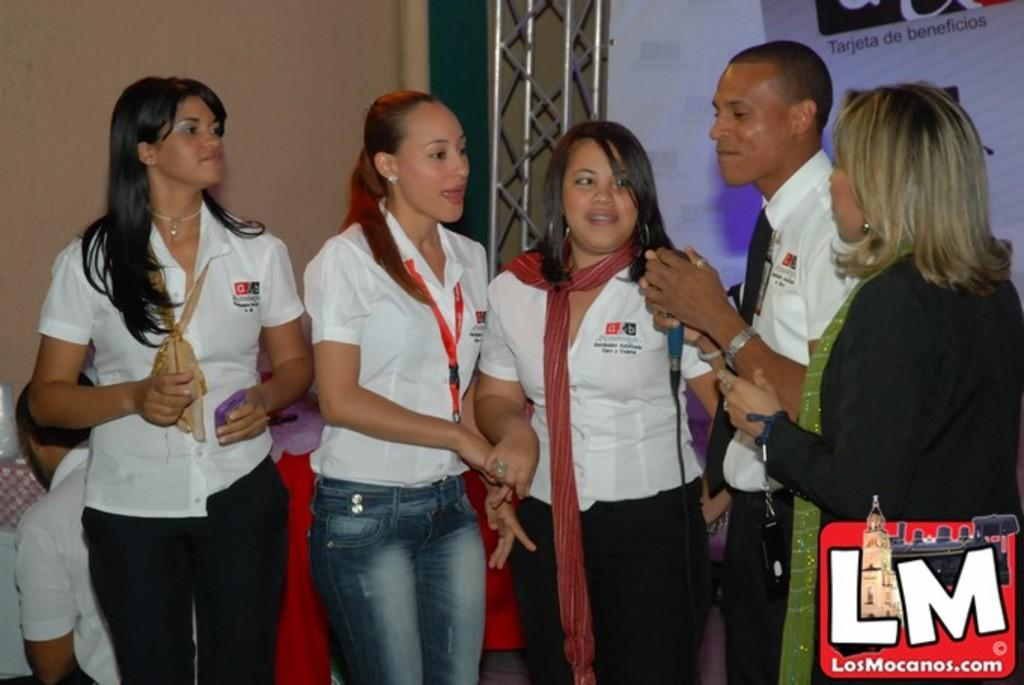What are the people in the image doing? The persons standing on the floor are likely engaged in some activity, as one of them is holding a mic in his hand. What can be seen in the background of the image? There are walls, a grill, an advertisement, and a person in the background. Can you describe the person holding the mic? Unfortunately, the provided facts do not give any specific details about the person holding the mic. Where is the pail located in the image? There is no pail present in the image. What type of book is the person in the background reading? There is no book visible in the image, and it is not clear if the person in the background is reading anything. 